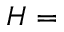Convert formula to latex. <formula><loc_0><loc_0><loc_500><loc_500>H =</formula> 